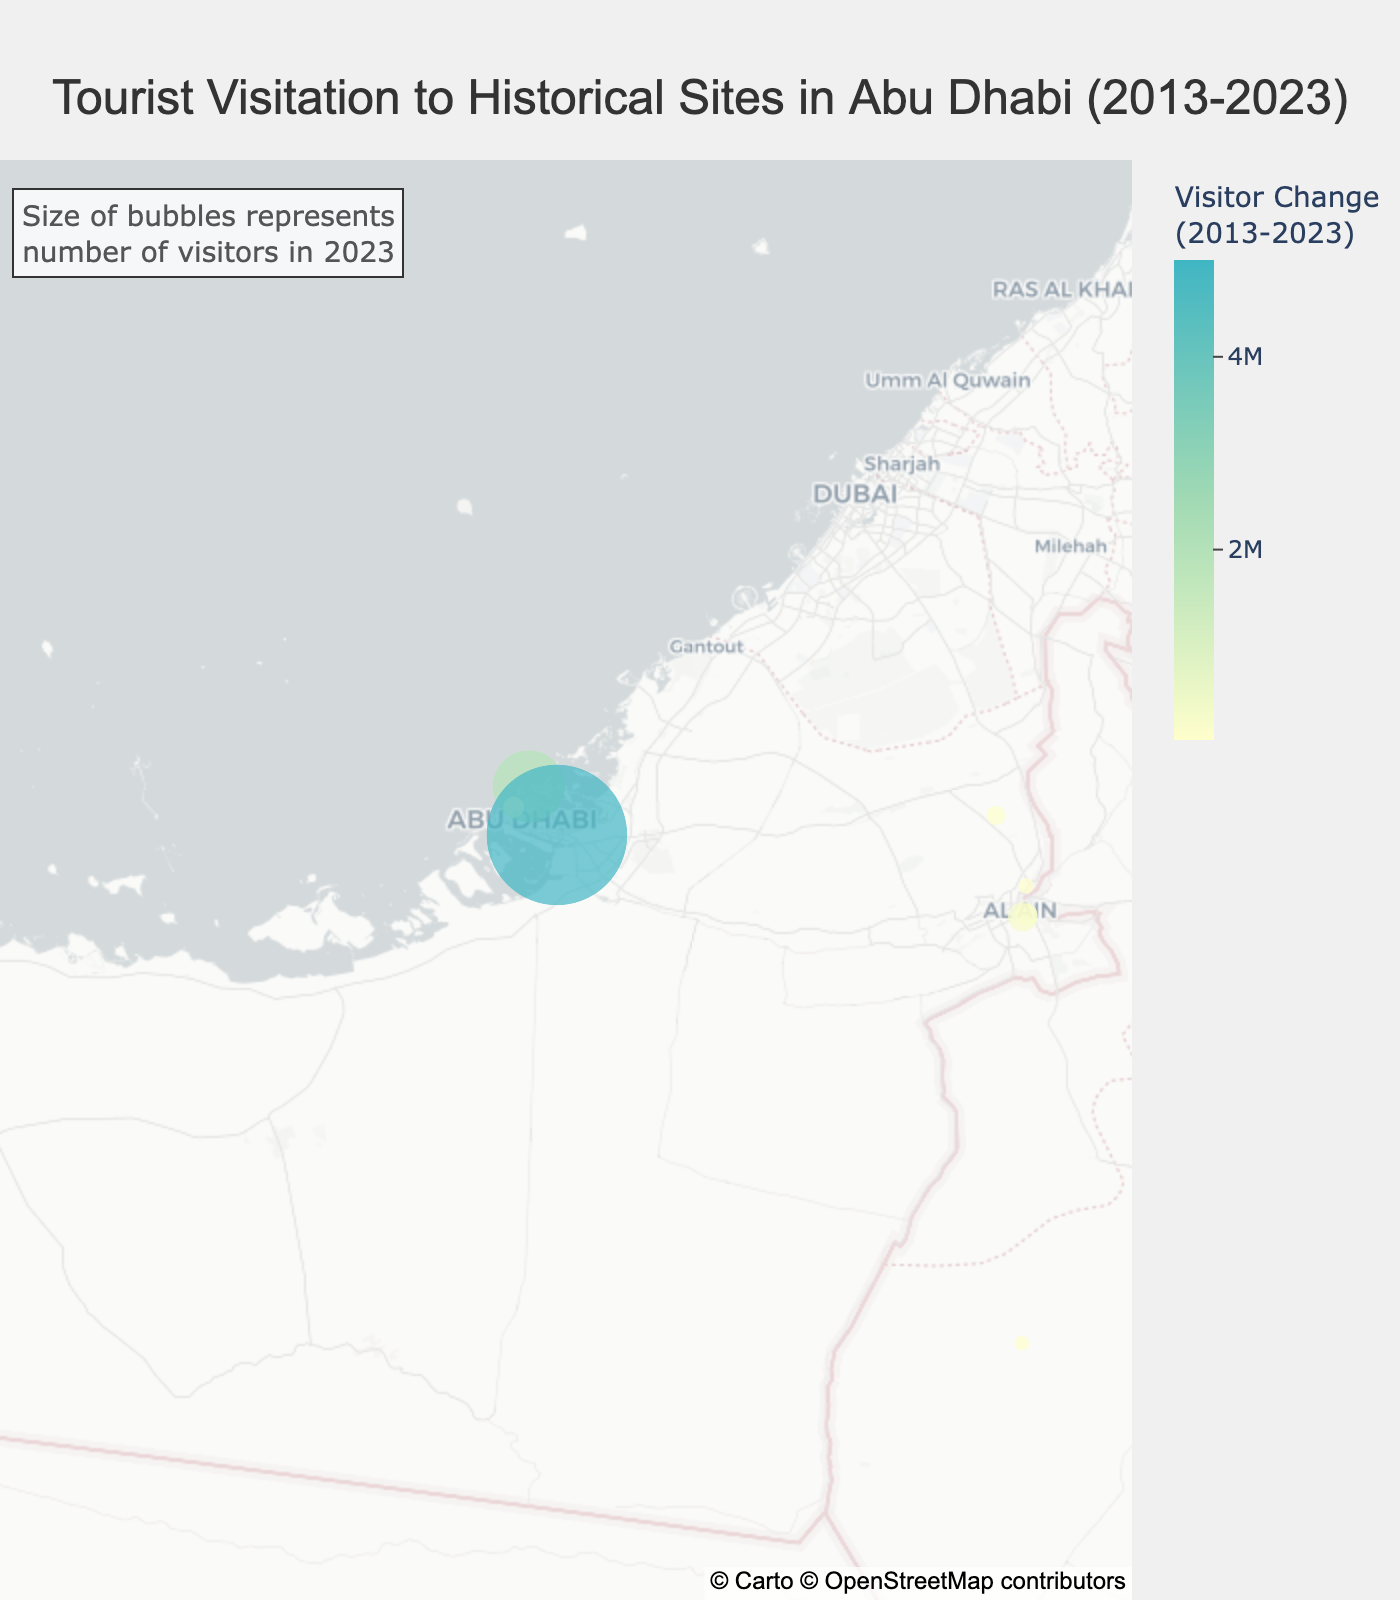How many sites are displayed on the map? Count the number of distinct sites displayed as bubbles on the map.
Answer: 10 Which site had the highest number of visitors in 2023? Look for the largest bubble on the map corresponding to the biggest value for the 2023 visitors.
Answer: Sheikh Zayed Grand Mosque What is the visitor count change for Louvre Abu Dhabi from 2013 to 2023? Find Louvre Abu Dhabi and subtract the 2013 visitor count from the 2023 visitor count.
Answer: 2,000,000 Which site experienced the smallest increase in visitors from 2013 to 2023? Identify the smallest positive visitor count change shown by the color scale.
Answer: Dalma Island What is the average number of visitors across all sites in 2023? Add up the 2023 visitor numbers for all sites and divide by the number of sites (10).
Answer: 1,158,000 How much did the number of visitors to Sir Bani Yas Island increase from 2018 to 2023? Subtract the 2018 visitors from the 2023 visitors for Sir Bani Yas Island.
Answer: 70,000 Which site had the smallest bubble on the map? Identify the site with the smallest visual bubble corresponding to the 2023 visitor count.
Answer: Dalma Island Which site has the largest increase in visitors between 2013 and 2023? Identify the site with the largest change in visitors using the color gradient.
Answer: Sheikh Zayed Grand Mosque Which sites had zero visitors in 2013? Identify the site that has a visitor count of zero in 2013.
Answer: Louvre Abu Dhabi Rank the sites based on the number of visitors in 2023 from highest to lowest. Order the sites by their 2023 visitor numbers (bubbles size) from largest to smallest.
Answer: Sheikh Zayed Grand Mosque, Louvre Abu Dhabi, Qasr Al Hosn, Al Ain Oasis, Al Jahili Fort, Al Ain Palace Museum, Sir Bani Yas Island, Hili Archaeological Park, Qasr Al Muwaiji, Dalma Island 